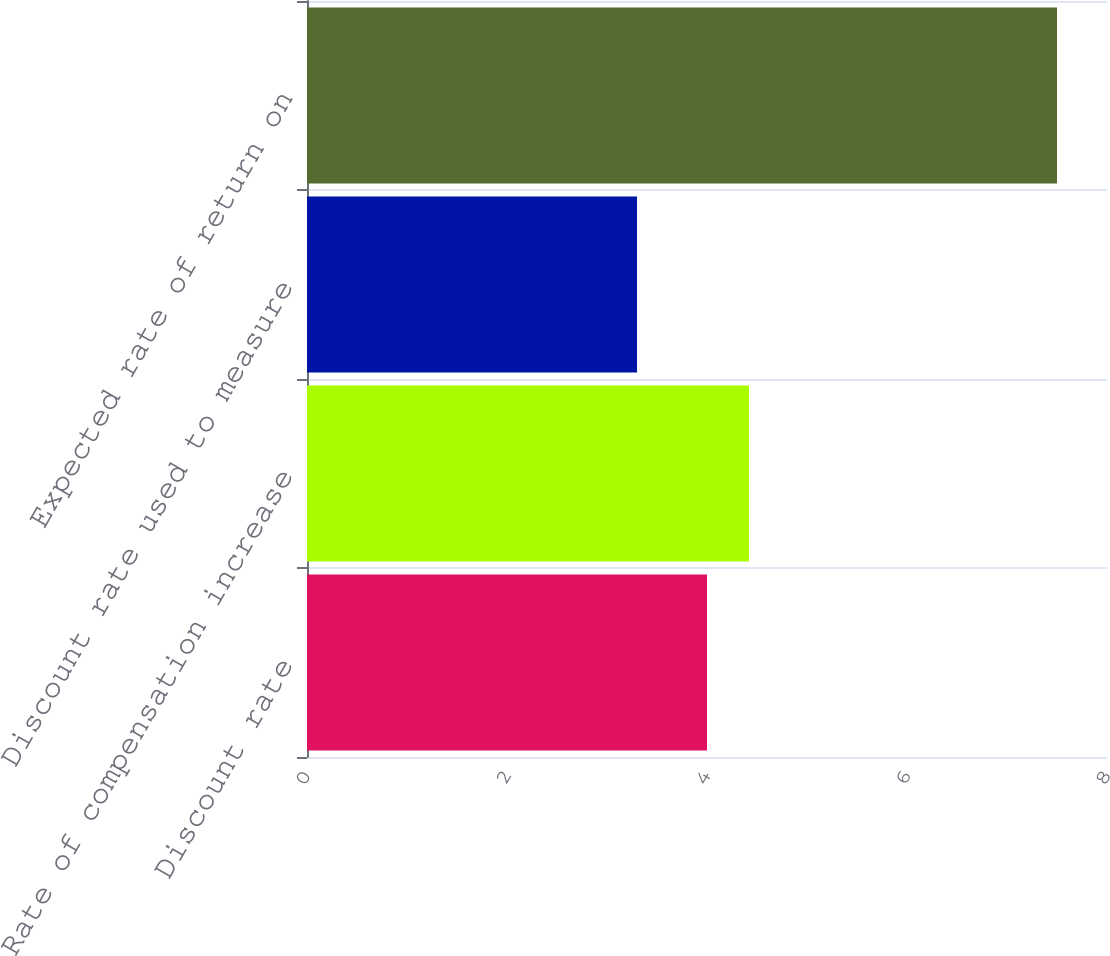Convert chart. <chart><loc_0><loc_0><loc_500><loc_500><bar_chart><fcel>Discount rate<fcel>Rate of compensation increase<fcel>Discount rate used to measure<fcel>Expected rate of return on<nl><fcel>4<fcel>4.42<fcel>3.3<fcel>7.5<nl></chart> 